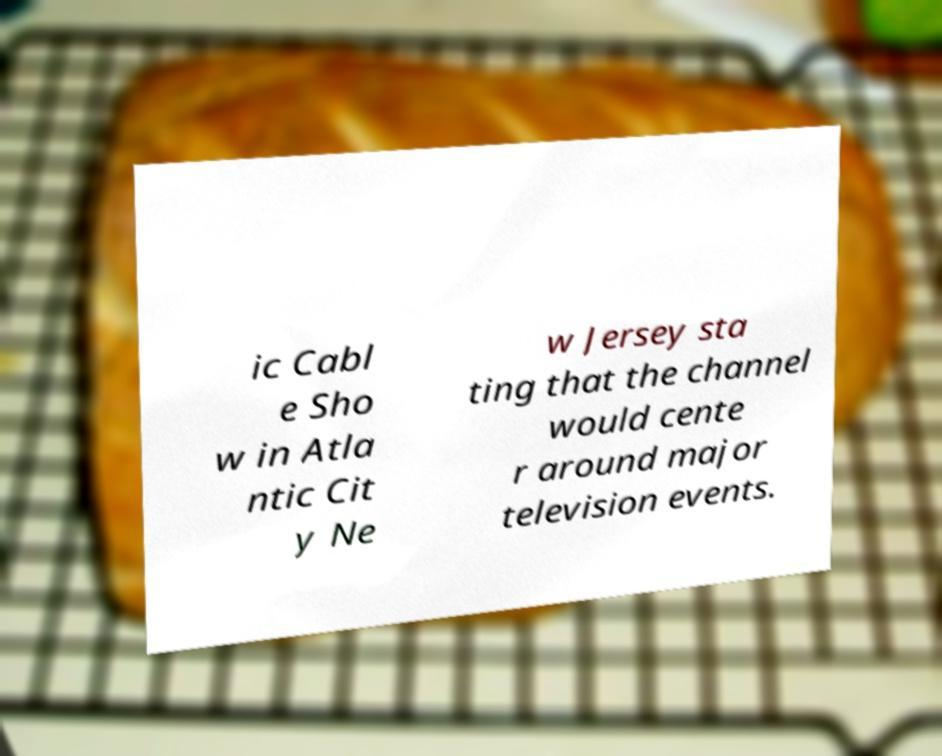For documentation purposes, I need the text within this image transcribed. Could you provide that? ic Cabl e Sho w in Atla ntic Cit y Ne w Jersey sta ting that the channel would cente r around major television events. 